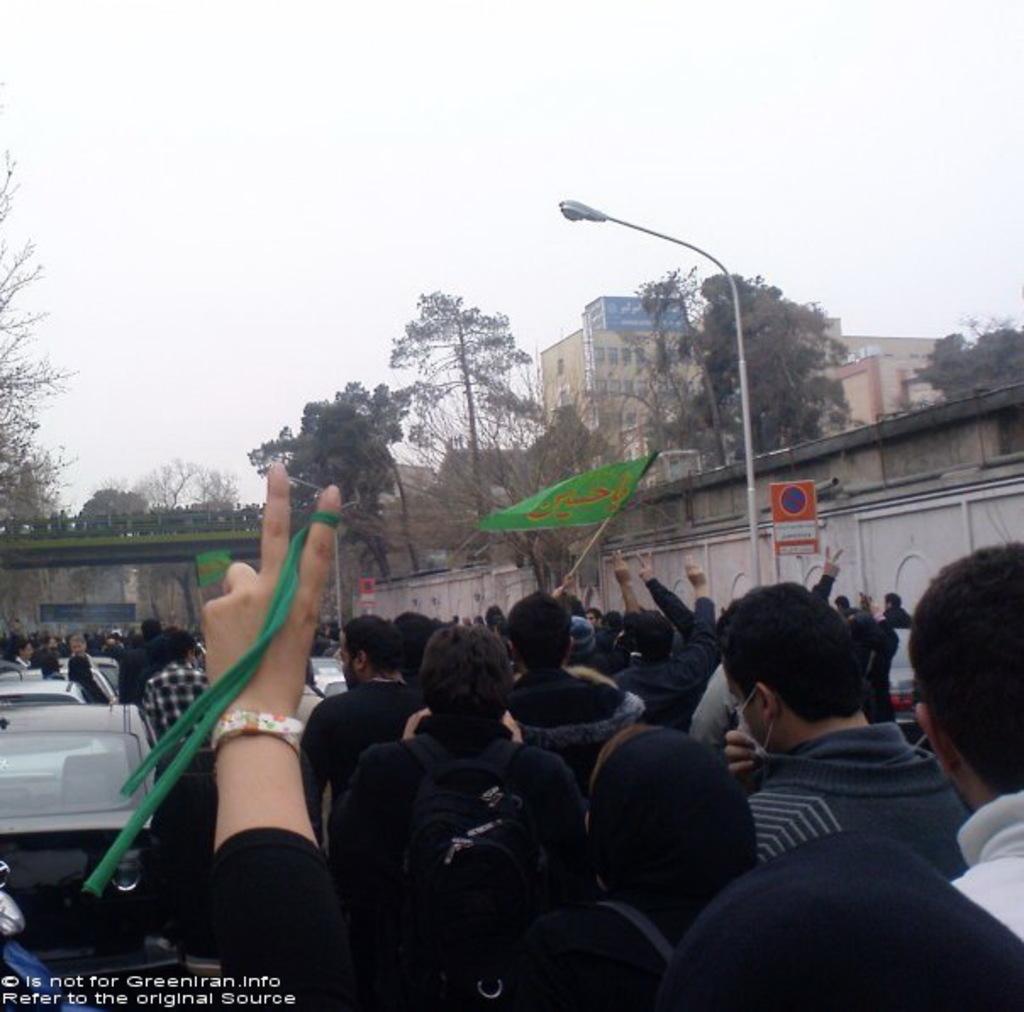In one or two sentences, can you explain what this image depicts? In this picture we can see there are groups of people. At the bottom of the image, there is a hand of a person. On the left side of the image there are vehicles. On the right side of the people, there is a signboard and there is a pole with light. In front of the people there is a bridge, trees, buildings and the sky. On the image there is a watermark. 